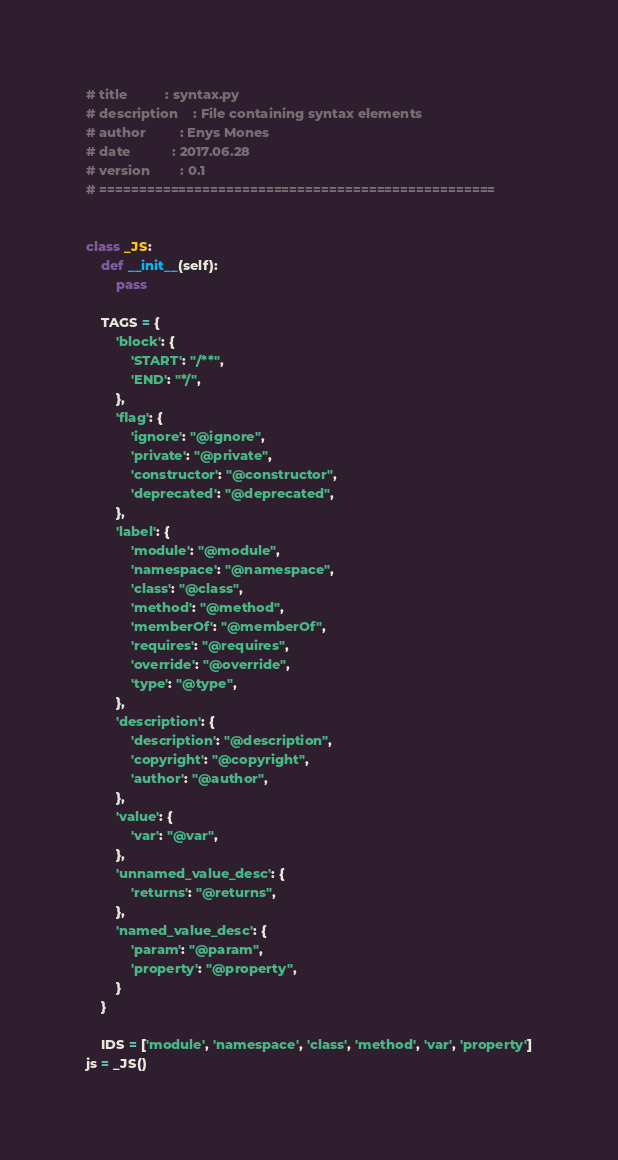<code> <loc_0><loc_0><loc_500><loc_500><_Python_># title          : syntax.py
# description    : File containing syntax elements
# author         : Enys Mones
# date           : 2017.06.28
# version        : 0.1
# ==================================================


class _JS:
    def __init__(self):
        pass

    TAGS = {
        'block': {
            'START': "/**",
            'END': "*/",
        },
        'flag': {
            'ignore': "@ignore",
            'private': "@private",
            'constructor': "@constructor",
            'deprecated': "@deprecated",
        },
        'label': {
            'module': "@module",
            'namespace': "@namespace",
            'class': "@class",
            'method': "@method",
            'memberOf': "@memberOf",
            'requires': "@requires",
            'override': "@override",
            'type': "@type",
        },
        'description': {
            'description': "@description",
            'copyright': "@copyright",
            'author': "@author",
        },
        'value': {
            'var': "@var",
        },
        'unnamed_value_desc': {
            'returns': "@returns",
        },
        'named_value_desc': {
            'param': "@param",
            'property': "@property",
        }
    }

    IDS = ['module', 'namespace', 'class', 'method', 'var', 'property']
js = _JS()
</code> 